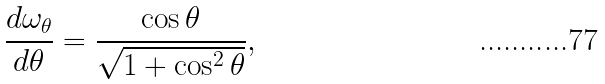<formula> <loc_0><loc_0><loc_500><loc_500>\frac { d \omega _ { \theta } } { d \theta } = \frac { \cos \theta } { \sqrt { 1 + \cos ^ { 2 } \theta } } ,</formula> 